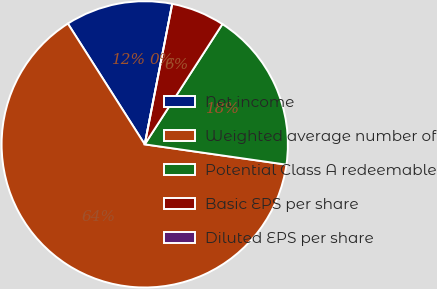Convert chart. <chart><loc_0><loc_0><loc_500><loc_500><pie_chart><fcel>Net income<fcel>Weighted average number of<fcel>Potential Class A redeemable<fcel>Basic EPS per share<fcel>Diluted EPS per share<nl><fcel>12.1%<fcel>63.71%<fcel>18.14%<fcel>6.05%<fcel>0.0%<nl></chart> 